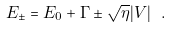Convert formula to latex. <formula><loc_0><loc_0><loc_500><loc_500>E _ { \pm } = E _ { 0 } + \Gamma \pm \sqrt { \eta } | V | \ .</formula> 